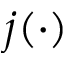<formula> <loc_0><loc_0><loc_500><loc_500>j ( \cdot )</formula> 